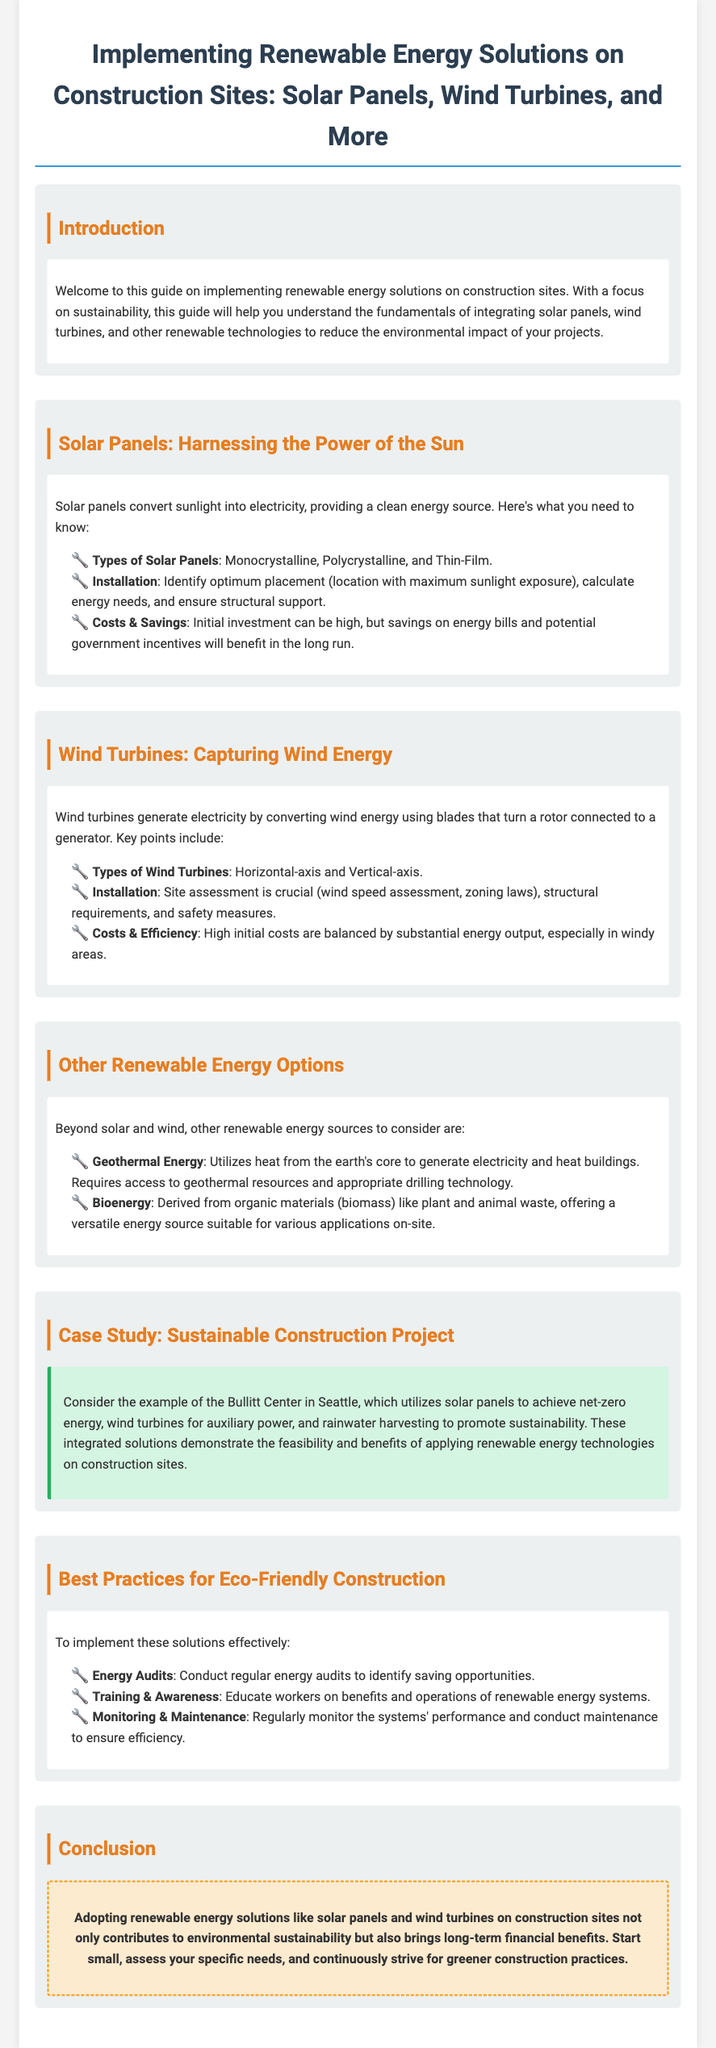What are the three types of solar panels? The document lists Monocrystalline, Polycrystalline, and Thin-Film as the types of solar panels.
Answer: Monocrystalline, Polycrystalline, Thin-Film What is the main purpose of installing solar panels? The document states that solar panels convert sunlight into electricity, providing a clean energy source.
Answer: Clean energy source What type of wind turbine is mentioned in the guide? The document mentions Horizontal-axis and Vertical-axis wind turbines.
Answer: Horizontal-axis, Vertical-axis What should be assessed for installing wind turbines? The guide emphasizes site assessment, including wind speed assessment and zoning laws, as crucial for installation.
Answer: Site assessment What is the Bullitt Center known for? The case study highlights the Bullitt Center's use of solar panels to achieve net-zero energy and wind turbines for auxiliary power.
Answer: Net-zero energy What renewable energy option utilizes heat from the earth's core? The document refers to Geothermal Energy as an option that utilizes heat from the earth's core.
Answer: Geothermal Energy What is a recommended best practice for eco-friendly construction? The guide recommends conducting regular energy audits to identify saving opportunities as a best practice.
Answer: Energy audits What is the significance of training and awareness according to the guide? The document highlights the importance of educating workers on the benefits and operations of renewable energy systems.
Answer: Educating workers In what way can adopting renewable energy solutions benefit construction sites? The conclusion states that such solutions contribute to environmental sustainability and bring long-term financial benefits.
Answer: Environmental sustainability and long-term financial benefits 